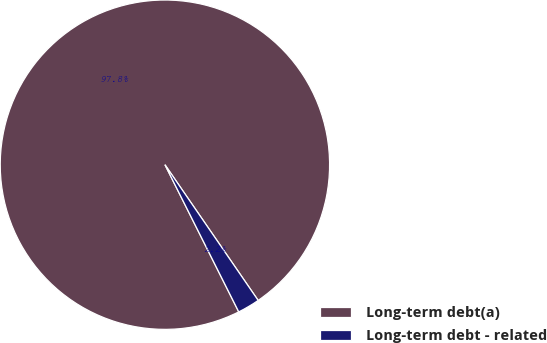<chart> <loc_0><loc_0><loc_500><loc_500><pie_chart><fcel>Long-term debt(a)<fcel>Long-term debt - related<nl><fcel>97.82%<fcel>2.18%<nl></chart> 